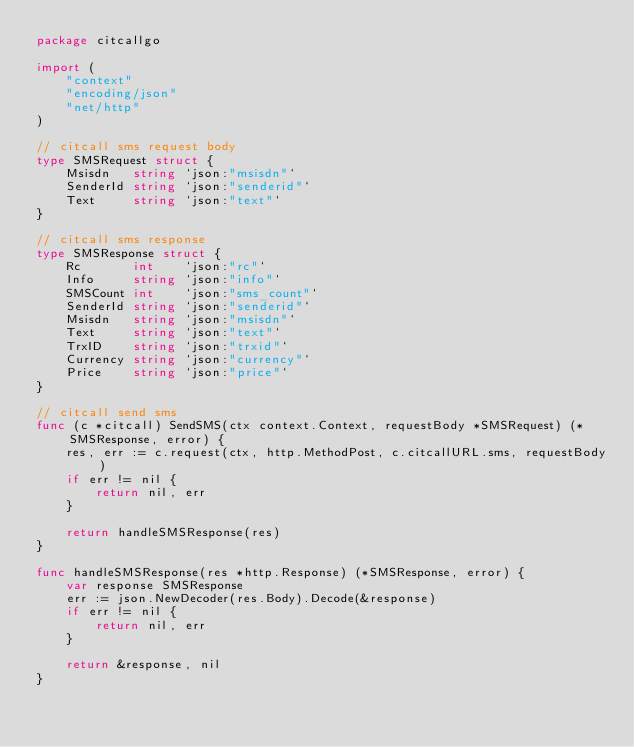Convert code to text. <code><loc_0><loc_0><loc_500><loc_500><_Go_>package citcallgo

import (
	"context"
	"encoding/json"
	"net/http"
)

// citcall sms request body
type SMSRequest struct {
	Msisdn   string `json:"msisdn"`
	SenderId string `json:"senderid"`
	Text     string `json:"text"`
}

// citcall sms response
type SMSResponse struct {
	Rc       int    `json:"rc"`
	Info     string `json:"info"`
	SMSCount int    `json:"sms_count"`
	SenderId string `json:"senderid"`
	Msisdn   string `json:"msisdn"`
	Text     string `json:"text"`
	TrxID    string `json:"trxid"`
	Currency string `json:"currency"`
	Price    string `json:"price"`
}

// citcall send sms
func (c *citcall) SendSMS(ctx context.Context, requestBody *SMSRequest) (*SMSResponse, error) {
	res, err := c.request(ctx, http.MethodPost, c.citcallURL.sms, requestBody)
	if err != nil {
		return nil, err
	}

	return handleSMSResponse(res)
}

func handleSMSResponse(res *http.Response) (*SMSResponse, error) {
	var response SMSResponse
	err := json.NewDecoder(res.Body).Decode(&response)
	if err != nil {
		return nil, err
	}

	return &response, nil
}
</code> 